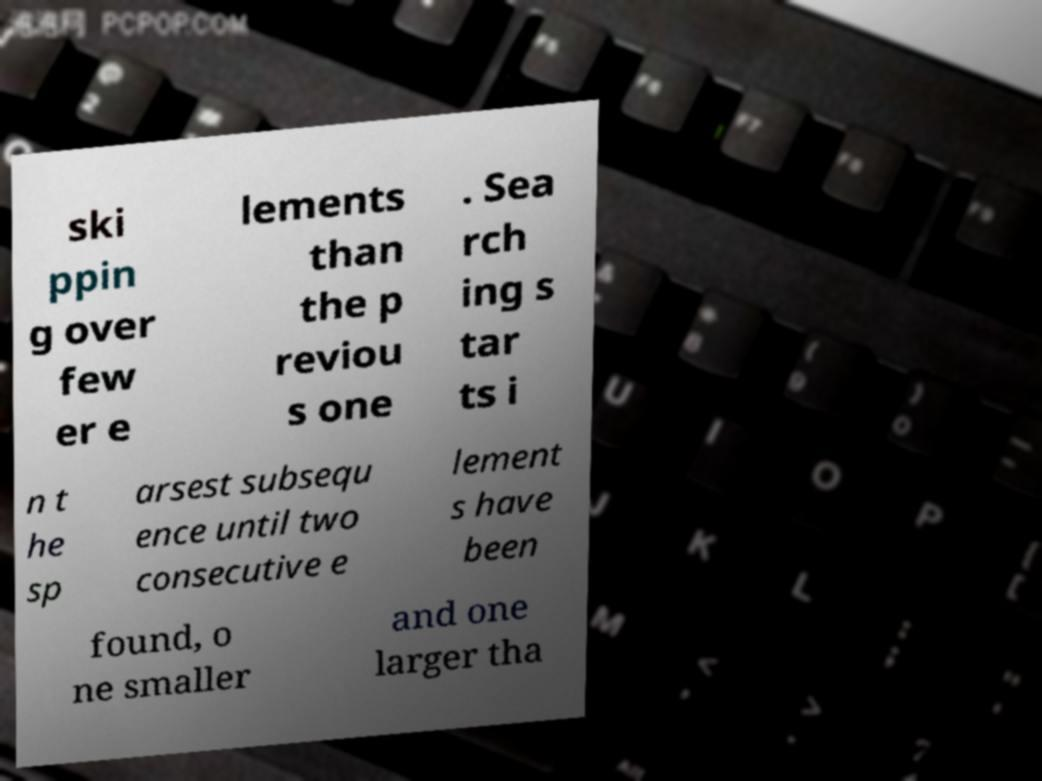What messages or text are displayed in this image? I need them in a readable, typed format. ski ppin g over few er e lements than the p reviou s one . Sea rch ing s tar ts i n t he sp arsest subsequ ence until two consecutive e lement s have been found, o ne smaller and one larger tha 